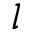Convert formula to latex. <formula><loc_0><loc_0><loc_500><loc_500>l</formula> 